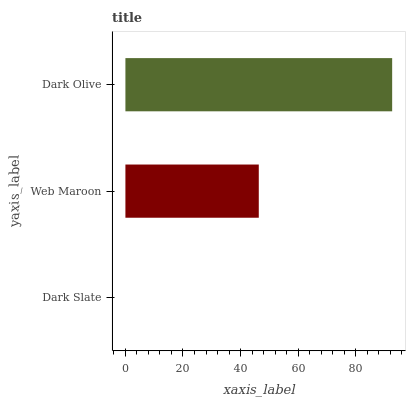Is Dark Slate the minimum?
Answer yes or no. Yes. Is Dark Olive the maximum?
Answer yes or no. Yes. Is Web Maroon the minimum?
Answer yes or no. No. Is Web Maroon the maximum?
Answer yes or no. No. Is Web Maroon greater than Dark Slate?
Answer yes or no. Yes. Is Dark Slate less than Web Maroon?
Answer yes or no. Yes. Is Dark Slate greater than Web Maroon?
Answer yes or no. No. Is Web Maroon less than Dark Slate?
Answer yes or no. No. Is Web Maroon the high median?
Answer yes or no. Yes. Is Web Maroon the low median?
Answer yes or no. Yes. Is Dark Slate the high median?
Answer yes or no. No. Is Dark Olive the low median?
Answer yes or no. No. 